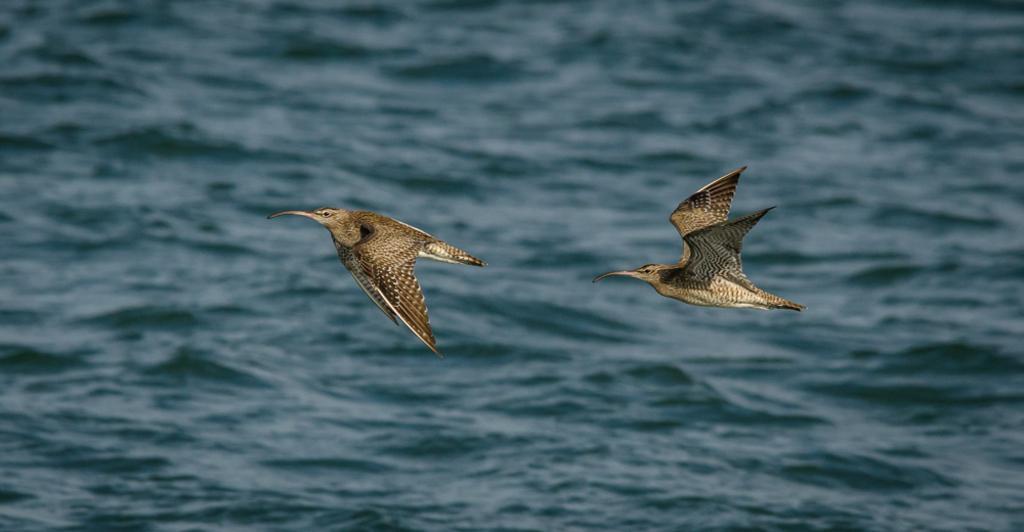In one or two sentences, can you explain what this image depicts? In this image there are birds flying in the sky. In the background there is water. 